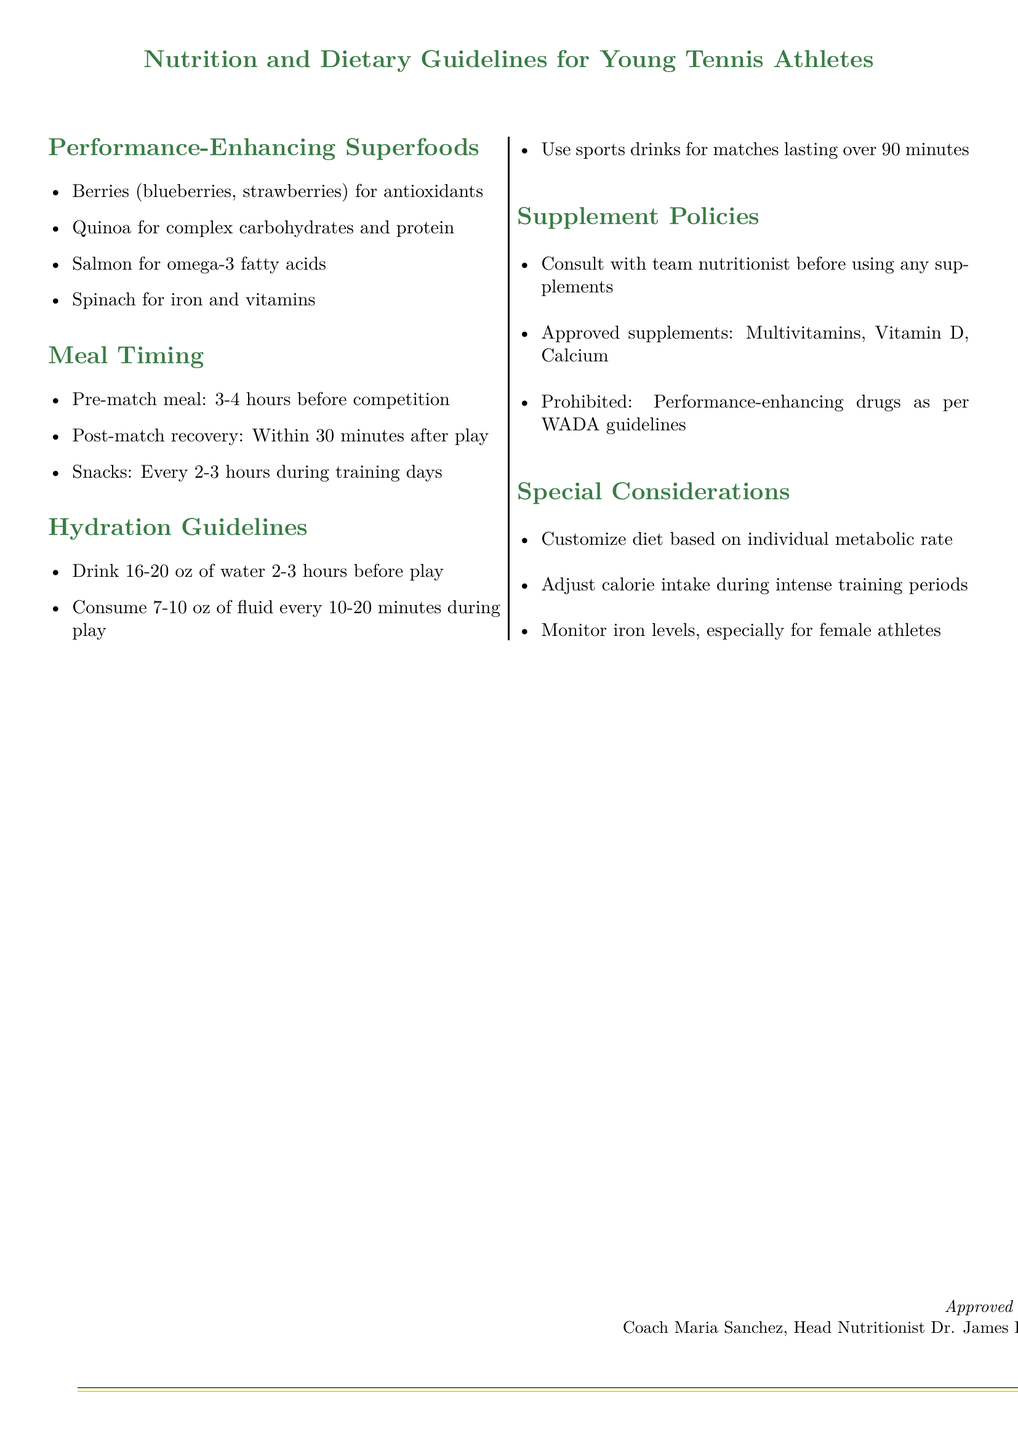What are two examples of performance-enhancing superfoods? The document lists specific superfoods that enhance performance in young tennis athletes. Two examples are listed as berries and quinoa.
Answer: Berries, quinoa How many ounces of water should be consumed 2-3 hours before play? This refers to the hydration guidelines which state the specific amount of water to be consumed before play. It states to drink 16-20 oz of water.
Answer: 16-20 oz What is the time frame for post-match recovery? The document specifies how soon after a match a recovery meal should be consumed. It indicates post-match recovery should occur within 30 minutes after play.
Answer: Within 30 minutes What kinds of supplements are prohibited according to the document? Supplement policies in the document mention restrictions on certain kinds of supplements during athletic competitions. Performance-enhancing drugs are prohibited.
Answer: Performance-enhancing drugs What are the approved supplements mentioned in the policy? The document explicitly mentions which supplements are approved for young tennis athletes in the supplement policies section. The approved supplements are listed as multivitamins, Vitamin D, and Calcium.
Answer: Multivitamins, Vitamin D, Calcium What should be monitored especially for female athletes? A special consideration in the document addresses specific health monitoring for a particular group of athletes. It states that iron levels should be monitored particularly for female athletes.
Answer: Iron levels How often should snacks be consumed during training days? The meal timing guidelines specify the frequency of snack consumption during training days. It states snacks should be consumed every 2-3 hours.
Answer: Every 2-3 hours Who approved the nutrition guidelines? The document features an approval section where the responsible individuals for the guidelines are listed. The names mentioned are Coach Maria Sanchez and Dr. James Lee.
Answer: Coach Maria Sanchez, Dr. James Lee 